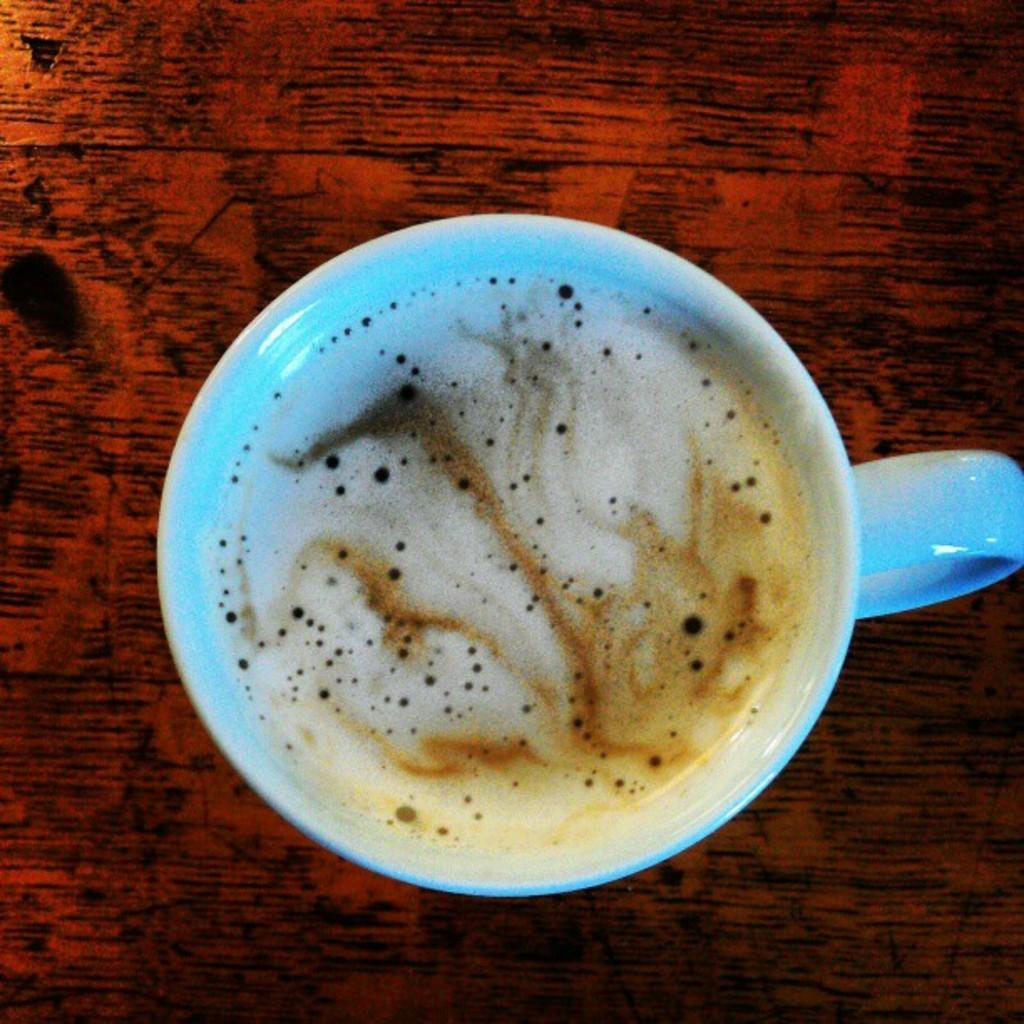What piece of furniture is present in the image? There is a table in the image. What is on the table in the image? There is a cup of coffee on the table. What type of curtain is hanging in the background of the image? There is no curtain visible in the image; it only features a table and a cup of coffee. 